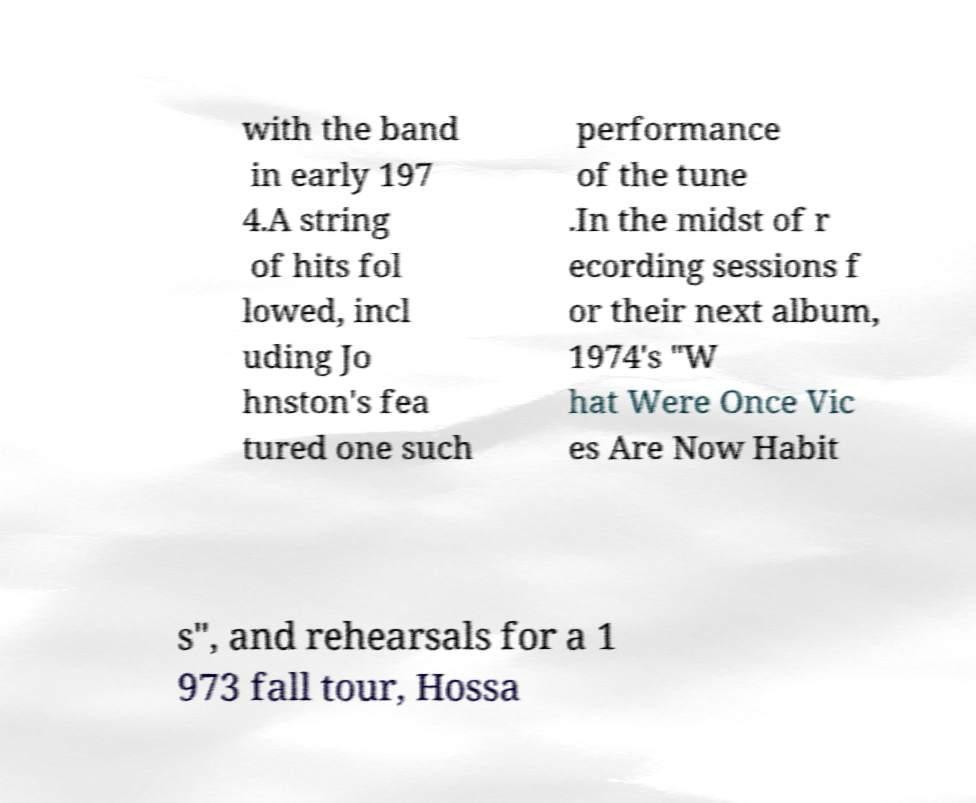Could you extract and type out the text from this image? with the band in early 197 4.A string of hits fol lowed, incl uding Jo hnston's fea tured one such performance of the tune .In the midst of r ecording sessions f or their next album, 1974's "W hat Were Once Vic es Are Now Habit s", and rehearsals for a 1 973 fall tour, Hossa 